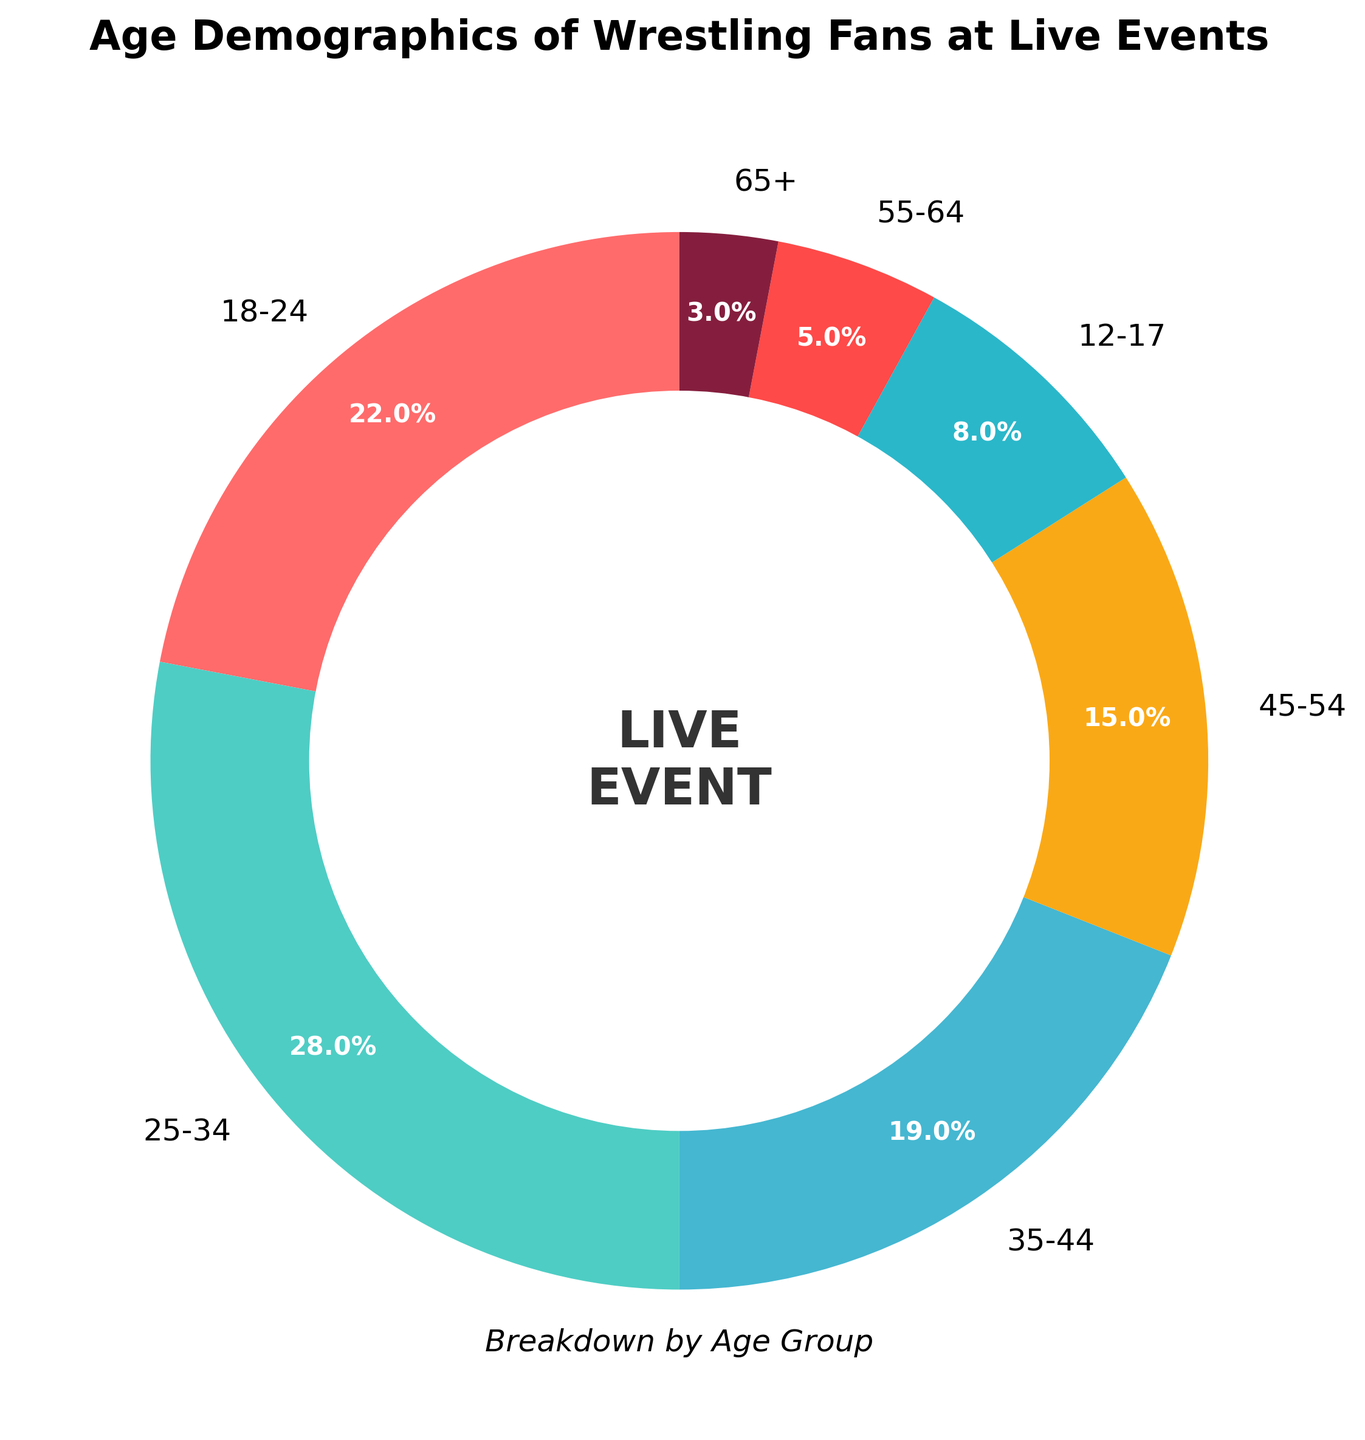What age group has the highest percentage of wrestling fans attending live events? The figure shows the age group percentages, and the 25-34 age group has the highest percentage among all the age groups.
Answer: 25-34 Which two age groups together make up more than 50% of the attendees? By adding the percentages for age groups: 18-24 (22%) and 25-34 (28%), the sum is 22% + 28% = 50%. This pair alone already makes up 50%.
Answer: 18-24 and 25-34 How much more percentage of wrestling fans are in the 18-24 age group compared to the 55-64 age group? Subtract the percentage of the 55-64 age group (5%) from the 18-24 age group (22%). The difference is 22% - 5% = 17%.
Answer: 17% Which age group has the lowest representation among the attendees? The figure demonstrates the percentage breakdown, and the 65+ age group has the lowest percentage at 3%.
Answer: 65+ What is the combined percentage of attendees aged 45 and above? Add the percentages for age groups: 45-54 (15%), 55-64 (5%), and 65+ (3%). The total is 15% + 5% + 3% = 23%.
Answer: 23% If the percentages for age groups 12-17 and 65+ are combined, are they more or less than the percentage for the 35-44 age group? Add the percentages for age groups: 12-17 (8%) and 65+ (3%). The total is 8% + 3% = 11%. Since this is less than the 35-44 age group (19%), their combined percentage is less.
Answer: Less Which age group is represented by a bright yellow color in the pie chart? Based on the distinctive coloring of the chart, the 45-54 age group is represented by a bright yellow color.
Answer: 45-54 Is the percentage of attendees in the 35-44 age group greater than twice that of the 55-64 age group? Double the percentage of the 55-64 age group (5%) is 10%. The percentage of the 35-44 age group is 19%, which is greater than 10%. Therefore, it is true.
Answer: Yes Is the combined percentage of the 18-24, 35-44, and 45-54 age groups higher than 60%? Add the percentages for age groups: 18-24 (22%), 35-44 (19%), and 45-54 (15%). The total is 22% + 19% + 15% = 56%, which is not higher than 60%.
Answer: No Which age groups have percentages that are less than the average percentage across all groups? First, calculate the average percentage by summing all the percentages (100%) and dividing by the number of groups (7): 100% / 7 ≈ 14.3%. The age groups with percentages less than this value are 12-17 (8%), 55-64 (5%), and 65+ (3%).
Answer: 12-17, 55-64, and 65+ 